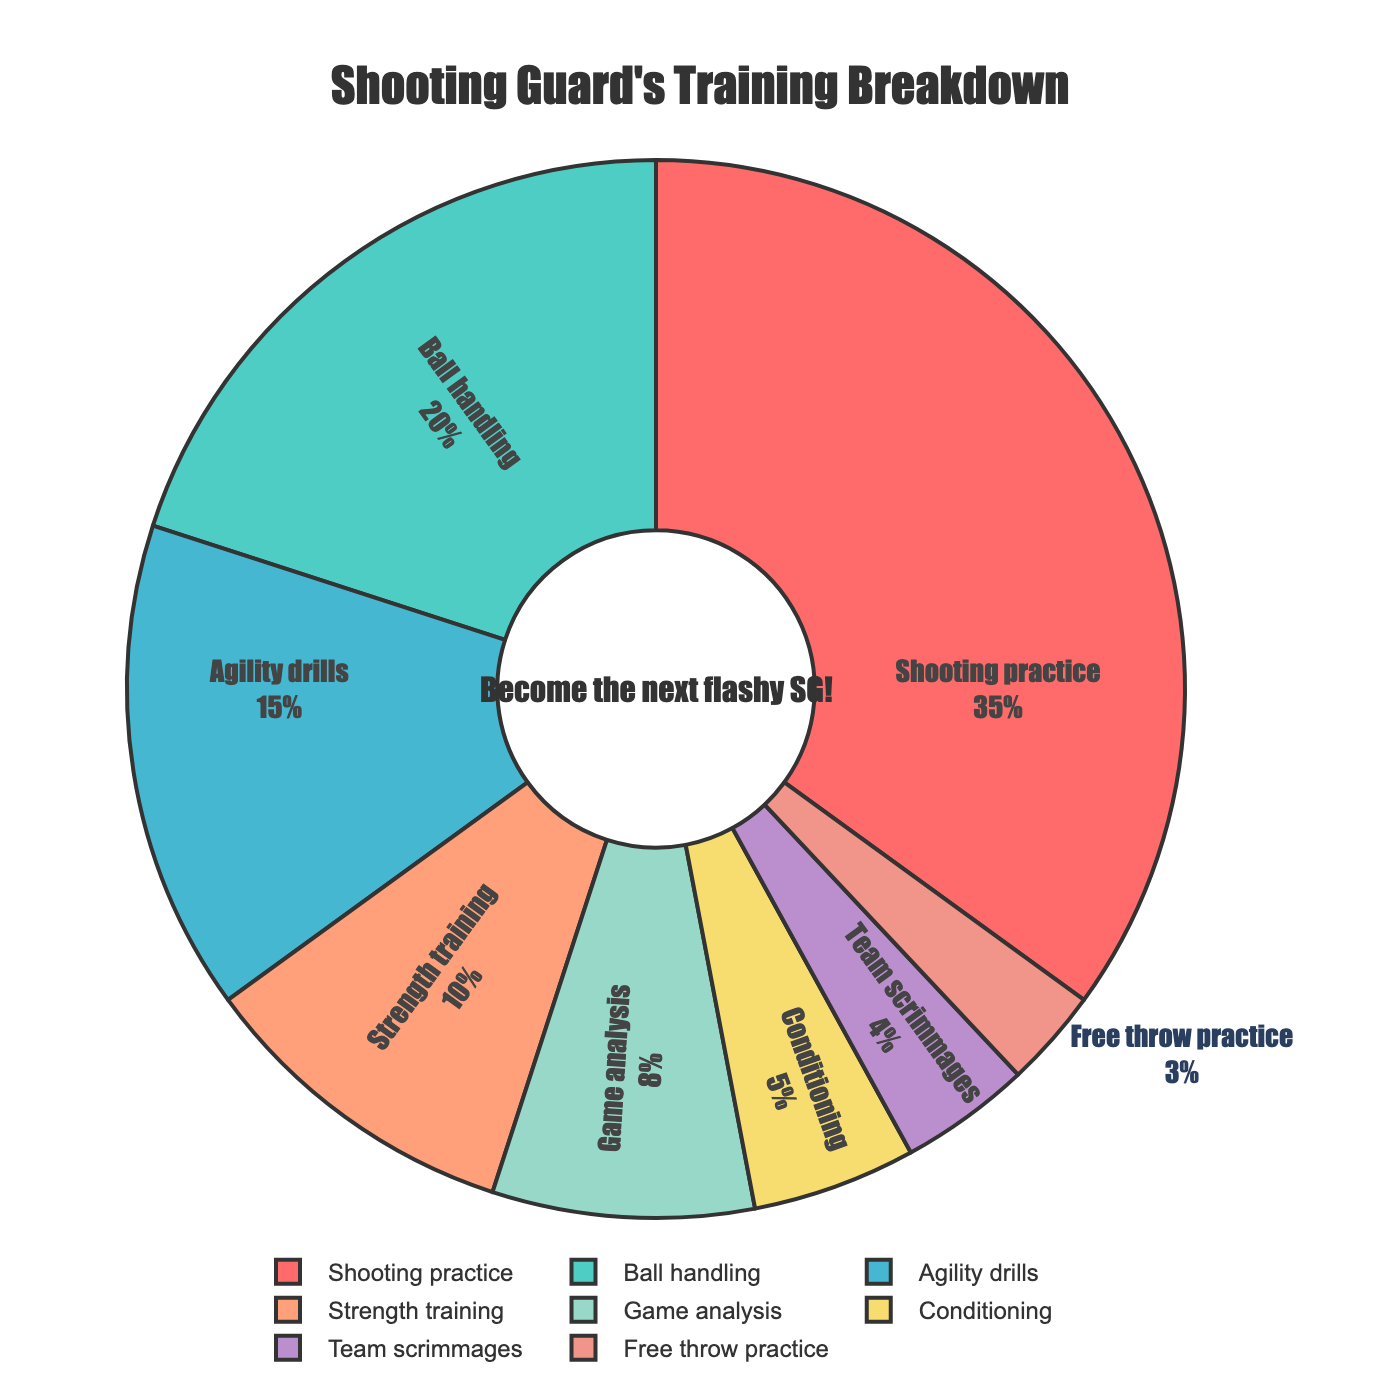Which activity takes up the most time? The activity with the highest percentage value is "Shooting practice" at 35%.
Answer: Shooting practice How much time is spent on game analysis compared to ball handling? Game analysis is 8%, while ball handling is 20%. Subtracting these values gives 20% - 8% = 12%. Therefore, 12% more time is spent on ball handling than on game analysis.
Answer: 12% more on ball handling Which activities combined make up half of the training time? Shooting practice is 35%, and ball handling is 20%. Adding these gives 35% + 20% = 55%. Thus, shooting practice and ball handling together make up more than half the training time.
Answer: Shooting practice and ball handling What is the total percentage of time spent on agility drills and free throw practice combined? Agility drills account for 15%, and free throw practice accounts for 3%. Adding these values gives 15% + 3% = 18%.
Answer: 18% Which activity has the smallest proportion of time dedicated to it? The activity with the smallest percentage value is "Free throw practice" at 3%.
Answer: Free throw practice Is more time spent on conditioning or team scrimmages? Conditioning is 5%, while team scrimmages are 4%. More time is spent on conditioning.
Answer: Conditioning How much more time is spent on strength training compared to free throw practice? Strength training accounts for 10%, and free throw practice accounts for 3%. Subtracting these values gives 10% - 3% = 7%. Therefore, 7% more time is spent on strength training.
Answer: 7% more What percentage of the training time is spent on activities other than shooting practice? Shooting practice is 35%, so other activities make up 100% - 35% = 65% of the training time.
Answer: 65% What's the difference in training time between conditioning and game analysis? Conditioning is 5%, and game analysis is 8%. The difference is 8% - 5% = 3%.
Answer: 3% What is the combined percentage of time spent on strength training, agility drills, and conditioning? Strength training is 10%, agility drills are 15%, and conditioning is 5%. Adding these values gives 10% + 15% + 5% = 30%.
Answer: 30% 